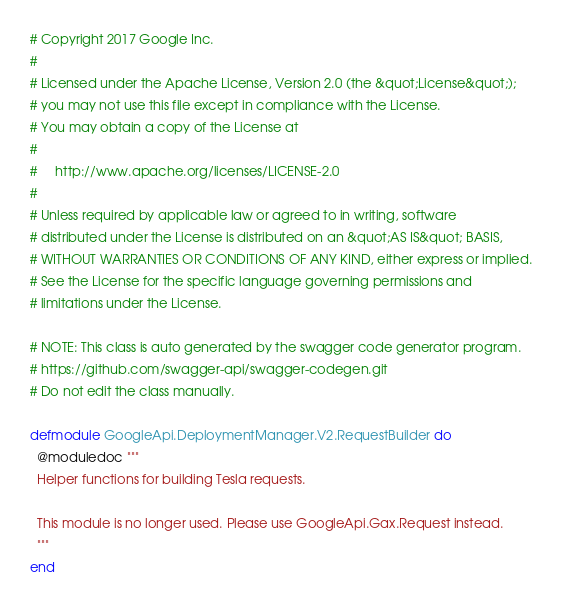<code> <loc_0><loc_0><loc_500><loc_500><_Elixir_># Copyright 2017 Google Inc.
#
# Licensed under the Apache License, Version 2.0 (the &quot;License&quot;);
# you may not use this file except in compliance with the License.
# You may obtain a copy of the License at
#
#     http://www.apache.org/licenses/LICENSE-2.0
#
# Unless required by applicable law or agreed to in writing, software
# distributed under the License is distributed on an &quot;AS IS&quot; BASIS,
# WITHOUT WARRANTIES OR CONDITIONS OF ANY KIND, either express or implied.
# See the License for the specific language governing permissions and
# limitations under the License.

# NOTE: This class is auto generated by the swagger code generator program.
# https://github.com/swagger-api/swagger-codegen.git
# Do not edit the class manually.

defmodule GoogleApi.DeploymentManager.V2.RequestBuilder do
  @moduledoc """
  Helper functions for building Tesla requests.

  This module is no longer used. Please use GoogleApi.Gax.Request instead.
  """
end
</code> 